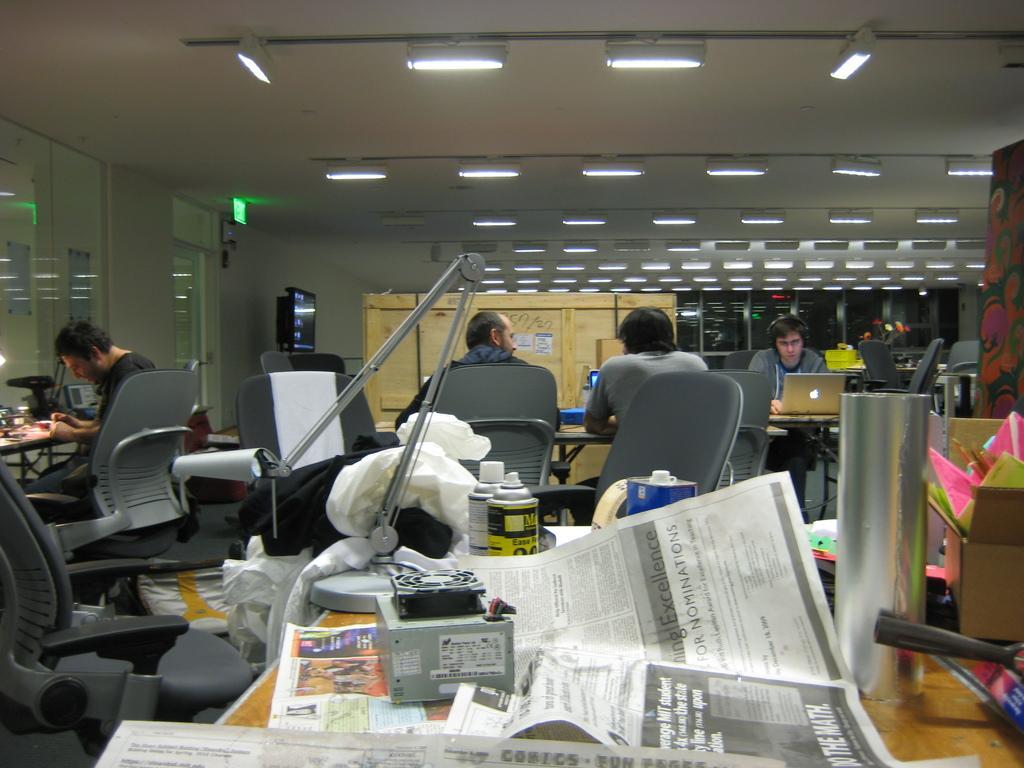How would you summarize this image in a sentence or two? This image is taken indoors. In the background there is a wall and there are two doors. There are a few cupboards. At the top of the image there is a ceiling with many lights. In the middle of the image a few are sitting in the chairs and doing work. There are a few empty chairs. There are many tables with many things on them. At the bottom of the image there is a table with a few newspapers, a device, bottles, a cardboard box with a few things and many things on it. 